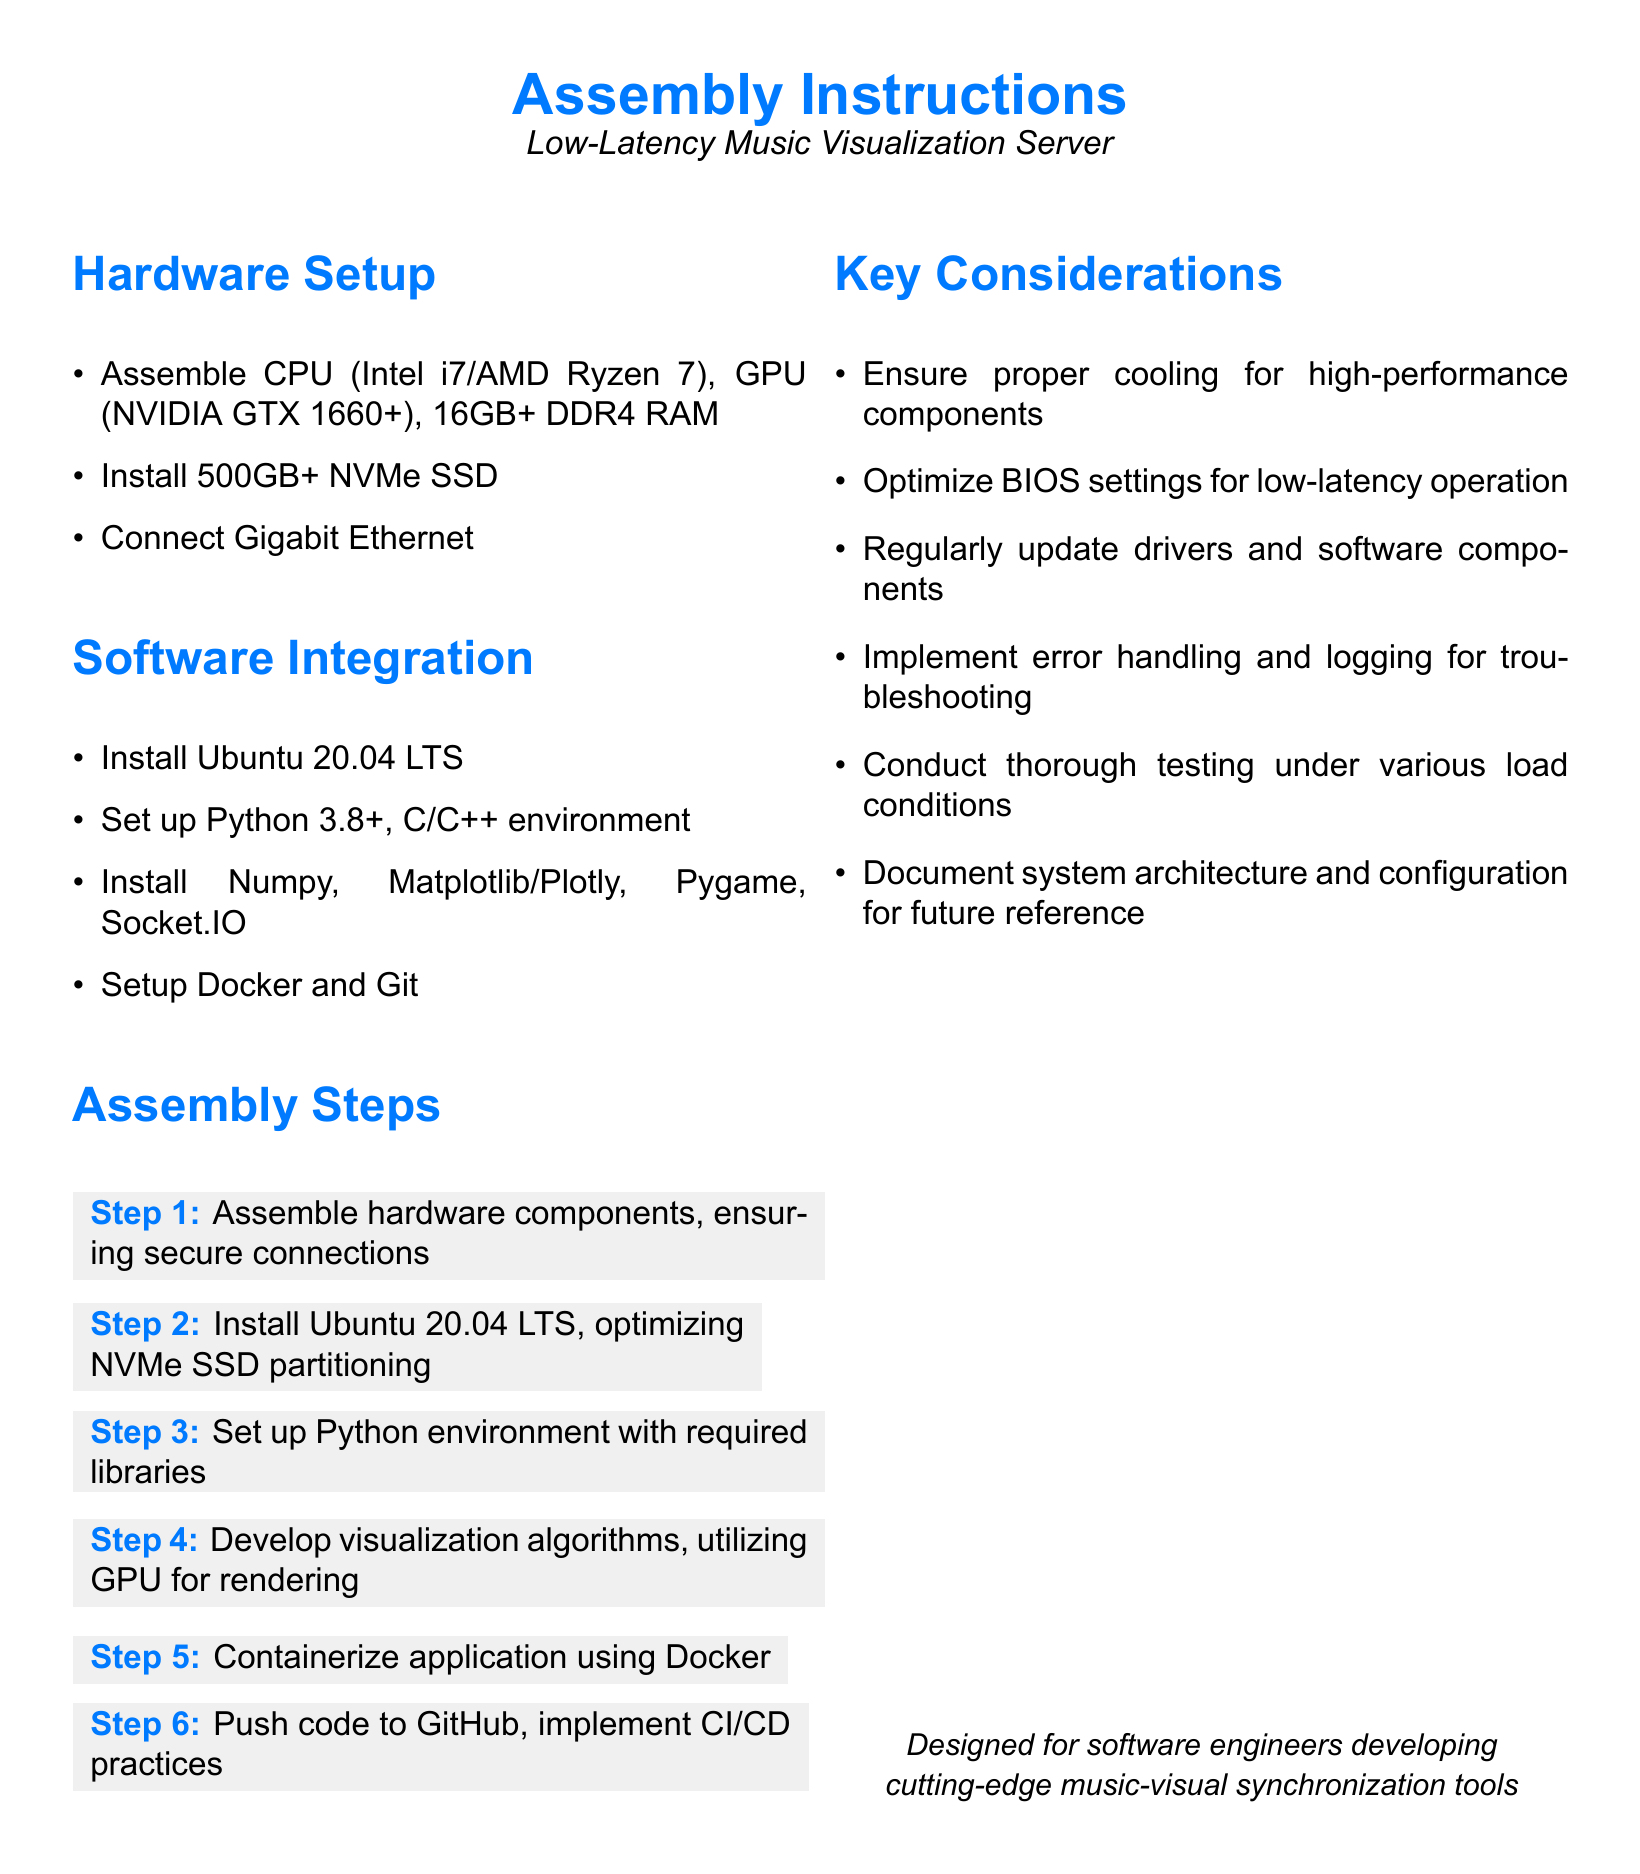what is the recommended CPU type? The document specifies the CPU types as Intel i7 or AMD Ryzen 7 for the hardware setup.
Answer: Intel i7/AMD Ryzen 7 what is the minimum RAM required? The document states that a minimum of 16GB DDR4 RAM is needed for the hardware setup.
Answer: 16GB which operating system should be installed? The assembly instructions recommend installing Ubuntu 20.04 LTS as the operating system.
Answer: Ubuntu 20.04 LTS which libraries should be installed? The document lists Numpy, Matplotlib/Plotly, Pygame, and Socket.IO as essential libraries for the software integration.
Answer: Numpy, Matplotlib/Plotly, Pygame, Socket.IO how many steps are in the assembly instructions? The document outlines six steps in the assembly process for building the server.
Answer: 6 what is the purpose of the software integration section? The section describes the necessary software components and setup needed for the server's functionality.
Answer: Software components which hardware component connects to Gigabit Ethernet? The document indicates that the hardware setup includes connecting a Gigabit Ethernet component.
Answer: Gigabit Ethernet what is the focus of the key considerations? The key considerations section highlights important aspects to ensure the server operates optimally.
Answer: Server operation what should be implemented for troubleshooting? The document advises implementing error handling and logging to assist with troubleshooting.
Answer: Error handling and logging 